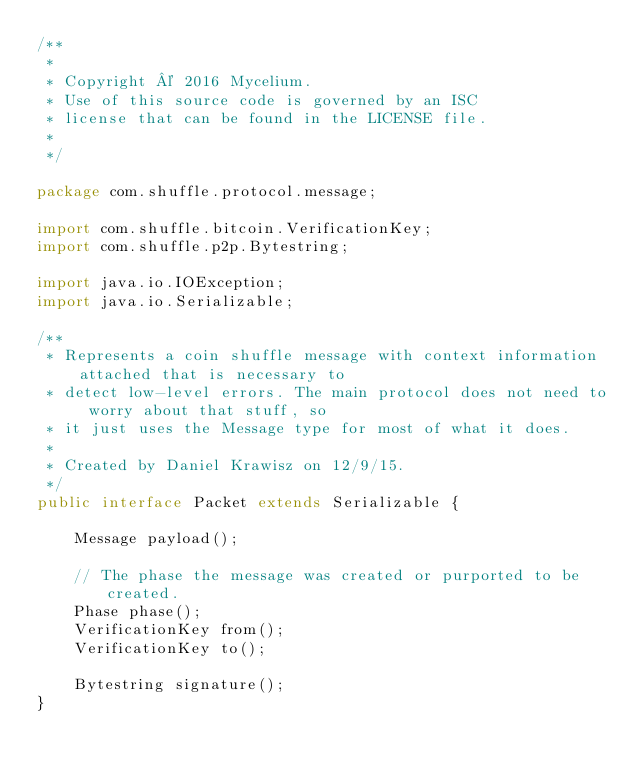<code> <loc_0><loc_0><loc_500><loc_500><_Java_>/**
 *
 * Copyright © 2016 Mycelium.
 * Use of this source code is governed by an ISC
 * license that can be found in the LICENSE file.
 *
 */

package com.shuffle.protocol.message;

import com.shuffle.bitcoin.VerificationKey;
import com.shuffle.p2p.Bytestring;

import java.io.IOException;
import java.io.Serializable;

/**
 * Represents a coin shuffle message with context information attached that is necessary to
 * detect low-level errors. The main protocol does not need to worry about that stuff, so
 * it just uses the Message type for most of what it does.
 *
 * Created by Daniel Krawisz on 12/9/15.
 */
public interface Packet extends Serializable {

    Message payload();

    // The phase the message was created or purported to be created.
    Phase phase();
    VerificationKey from();
    VerificationKey to();

    Bytestring signature();
}
</code> 